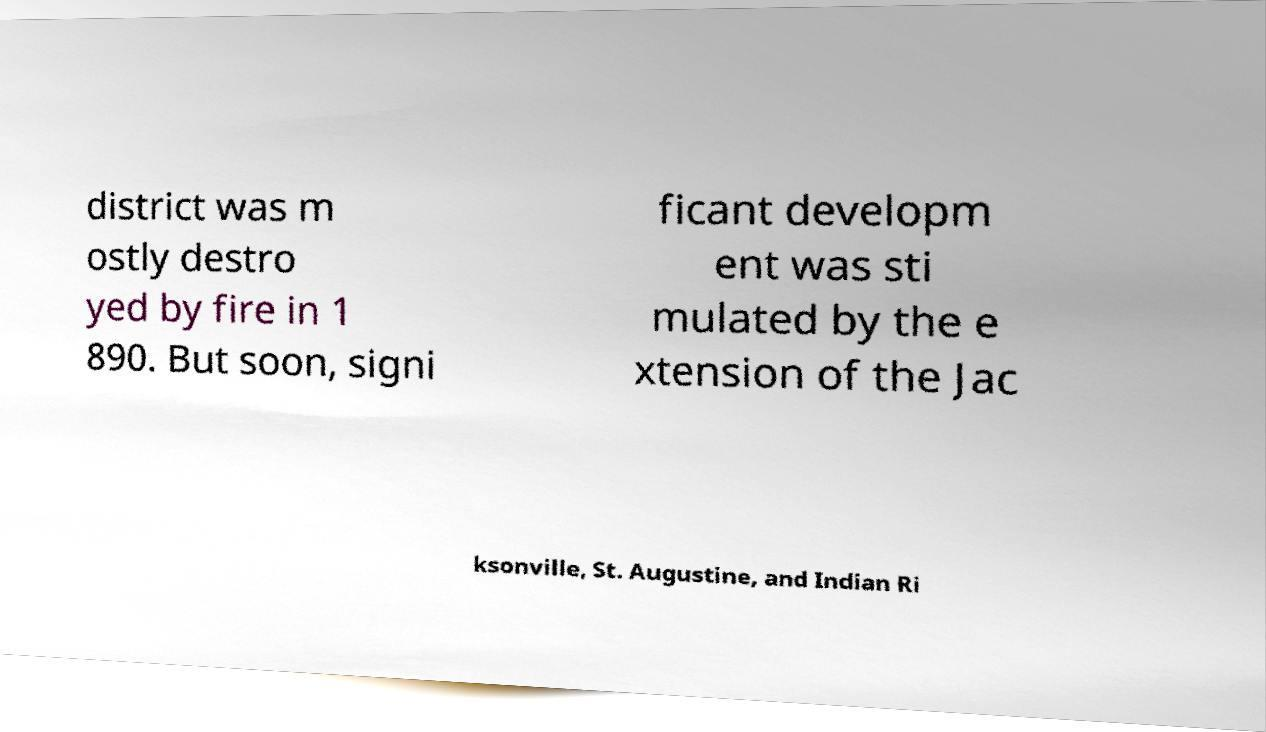For documentation purposes, I need the text within this image transcribed. Could you provide that? district was m ostly destro yed by fire in 1 890. But soon, signi ficant developm ent was sti mulated by the e xtension of the Jac ksonville, St. Augustine, and Indian Ri 